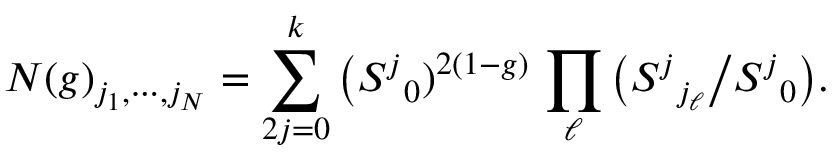Convert formula to latex. <formula><loc_0><loc_0><loc_500><loc_500>N ( g ) _ { j _ { 1 } , \cdots , j _ { N } } = \sum _ { 2 j = 0 } ^ { k } \Big ( S ^ { j _ { 0 } ) ^ { 2 ( 1 - g ) } \, \prod _ { \ell } \Big ( S ^ { j _ { j _ { \ell } } \Big / S ^ { j _ { 0 } \Big ) .</formula> 